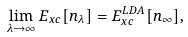Convert formula to latex. <formula><loc_0><loc_0><loc_500><loc_500>\lim _ { \lambda \rightarrow \infty } E _ { x c } [ n _ { \lambda } ] = E _ { x c } ^ { L D A } [ n _ { \infty } ] ,</formula> 